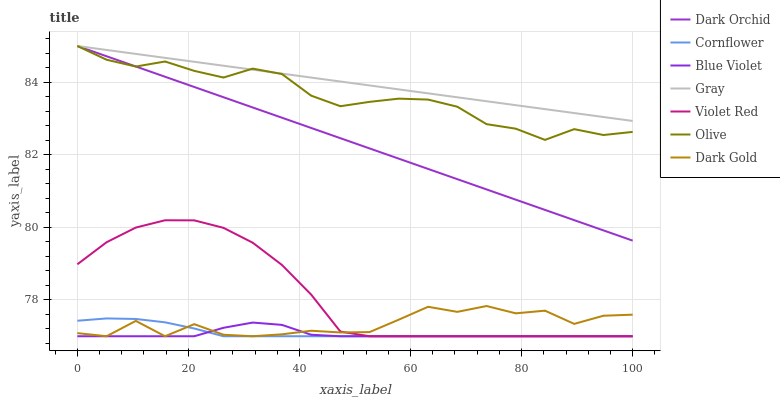Does Blue Violet have the minimum area under the curve?
Answer yes or no. Yes. Does Gray have the maximum area under the curve?
Answer yes or no. Yes. Does Violet Red have the minimum area under the curve?
Answer yes or no. No. Does Violet Red have the maximum area under the curve?
Answer yes or no. No. Is Dark Orchid the smoothest?
Answer yes or no. Yes. Is Dark Gold the roughest?
Answer yes or no. Yes. Is Violet Red the smoothest?
Answer yes or no. No. Is Violet Red the roughest?
Answer yes or no. No. Does Cornflower have the lowest value?
Answer yes or no. Yes. Does Gray have the lowest value?
Answer yes or no. No. Does Olive have the highest value?
Answer yes or no. Yes. Does Violet Red have the highest value?
Answer yes or no. No. Is Cornflower less than Olive?
Answer yes or no. Yes. Is Gray greater than Cornflower?
Answer yes or no. Yes. Does Cornflower intersect Violet Red?
Answer yes or no. Yes. Is Cornflower less than Violet Red?
Answer yes or no. No. Is Cornflower greater than Violet Red?
Answer yes or no. No. Does Cornflower intersect Olive?
Answer yes or no. No. 